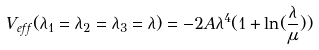<formula> <loc_0><loc_0><loc_500><loc_500>V _ { e f f } ( \lambda _ { 1 } = \lambda _ { 2 } = \lambda _ { 3 } = \lambda ) = - 2 A \lambda ^ { 4 } ( 1 + \ln ( \frac { \lambda } { \mu } ) )</formula> 